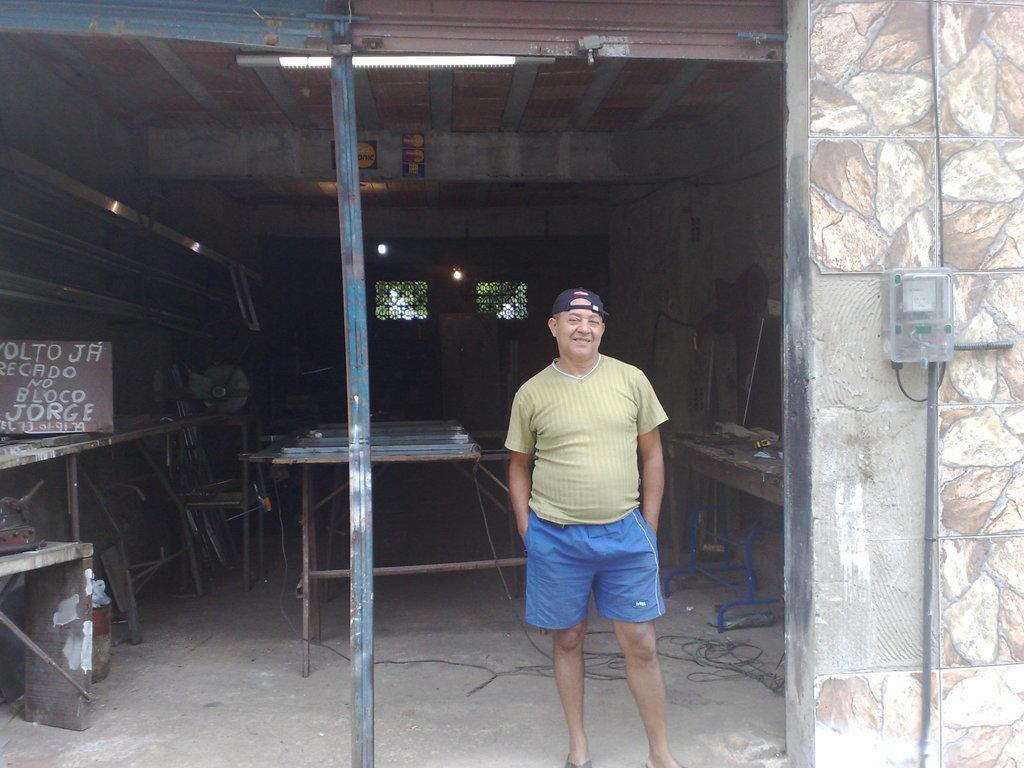<image>
Summarize the visual content of the image. A handmade wooden sign includes the name Jorge on it in white lettering. 